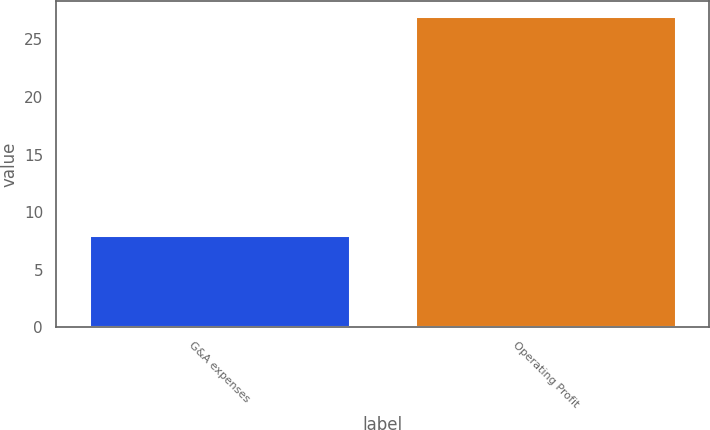Convert chart. <chart><loc_0><loc_0><loc_500><loc_500><bar_chart><fcel>G&A expenses<fcel>Operating Profit<nl><fcel>8<fcel>27<nl></chart> 